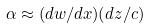<formula> <loc_0><loc_0><loc_500><loc_500>\alpha \approx ( d w / d x ) ( d z / c )</formula> 